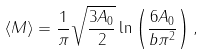<formula> <loc_0><loc_0><loc_500><loc_500>\langle M \rangle = \frac { 1 } { \pi } \sqrt { \frac { 3 A _ { 0 } } { 2 } } \ln \left ( \frac { 6 A _ { 0 } } { b \pi ^ { 2 } } \right ) ,</formula> 